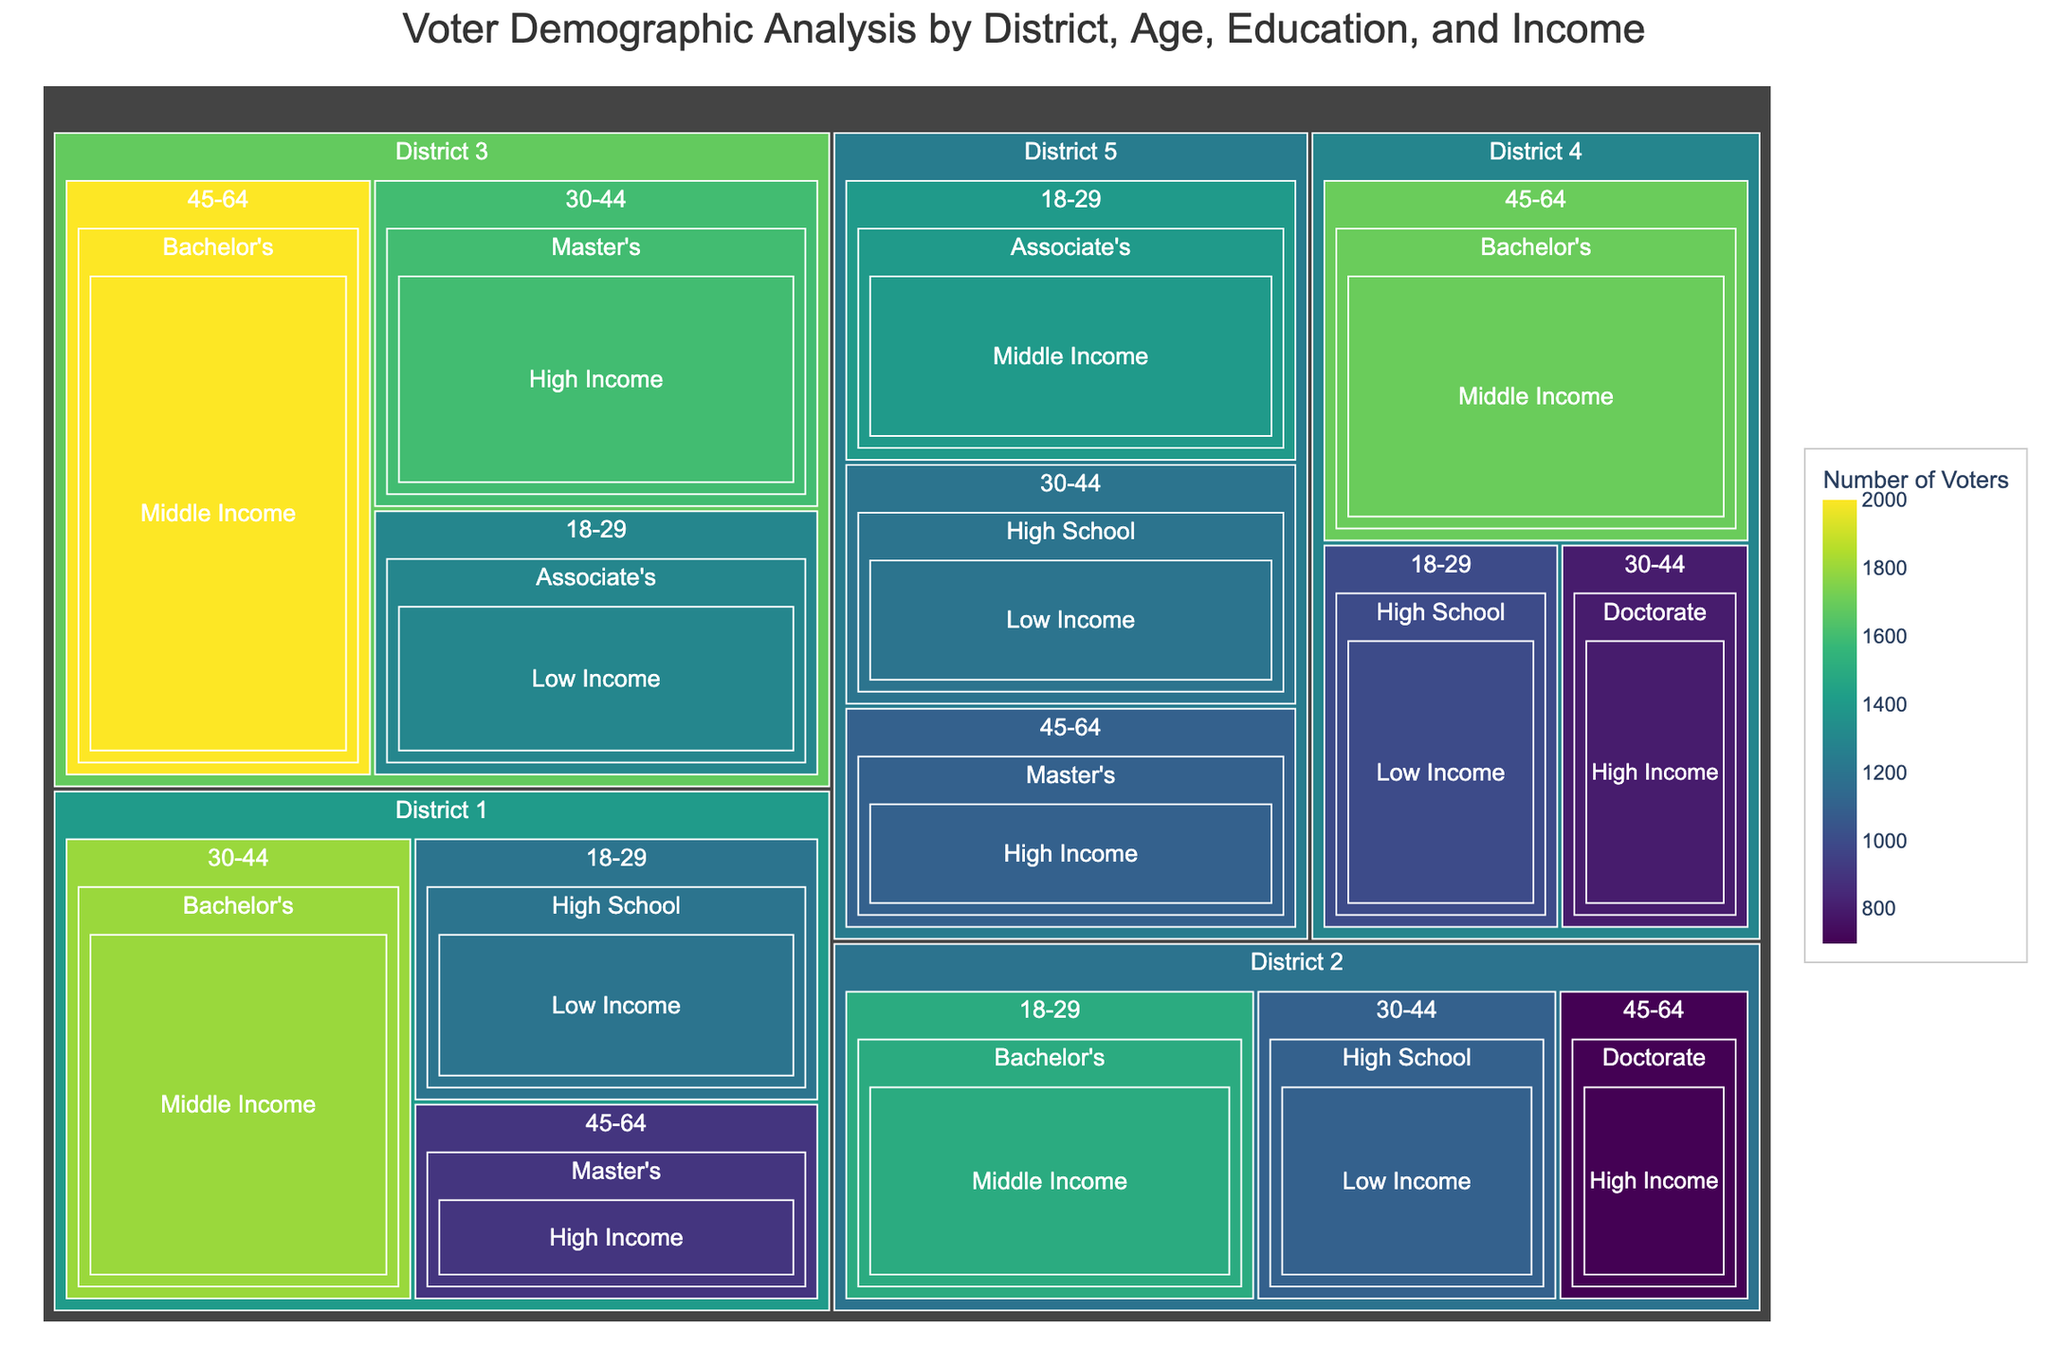What is the title of the treemap? The title is usually located at the top of the figure and indicates the subject of the analysis.
Answer: Voter Demographic Analysis by District, Age, Education, and Income Which district has the highest number of voters in the 18-29 age group? Look for the district with the largest/most prominent segment under the '18-29' age group within the figure.
Answer: District 2 What is the most common education level for voters in District 3? Identify the largest segment within District 3 based on education levels.
Answer: Bachelor's How many voters are there in total in District 1? To find the total, sum the number of voters from all age, education, and income groups in District 1: 1200 + 1800 + 900.
Answer: 3900 Which age group in District 4 has the least number of voters? Compare the size of segments corresponding to different age groups within District 4; select the smallest one.
Answer: 30-44 Comparing District 1 and District 5, which has more voters in the High School education level? Look at the segments labeled 'High School' in both districts and compare their sizes.
Answer: District 5 What income level has the highest number of voters in District 2? Check the largest segments grouped by income levels in District 2.
Answer: Middle Income Which district has the most total voters regardless of demographics? Sum the voter numbers for each district and compare the totals. District 3 has 1300 + 1600 + 2000, District 2 has 1500 + 1100 + 700, etc. District 3 totals the most.
Answer: District 3 How does the number of voters in the Masters education level compare across District 1 and District 3? Compare the segments labeled 'Master's' in both District 1 and District 3.
Answer: 900 (District 1) vs. 1600 (District 3) Which district has the highest number of low-income voters? Check the segments grouped under 'Low Income' and compare across all districts.
Answer: District 1 